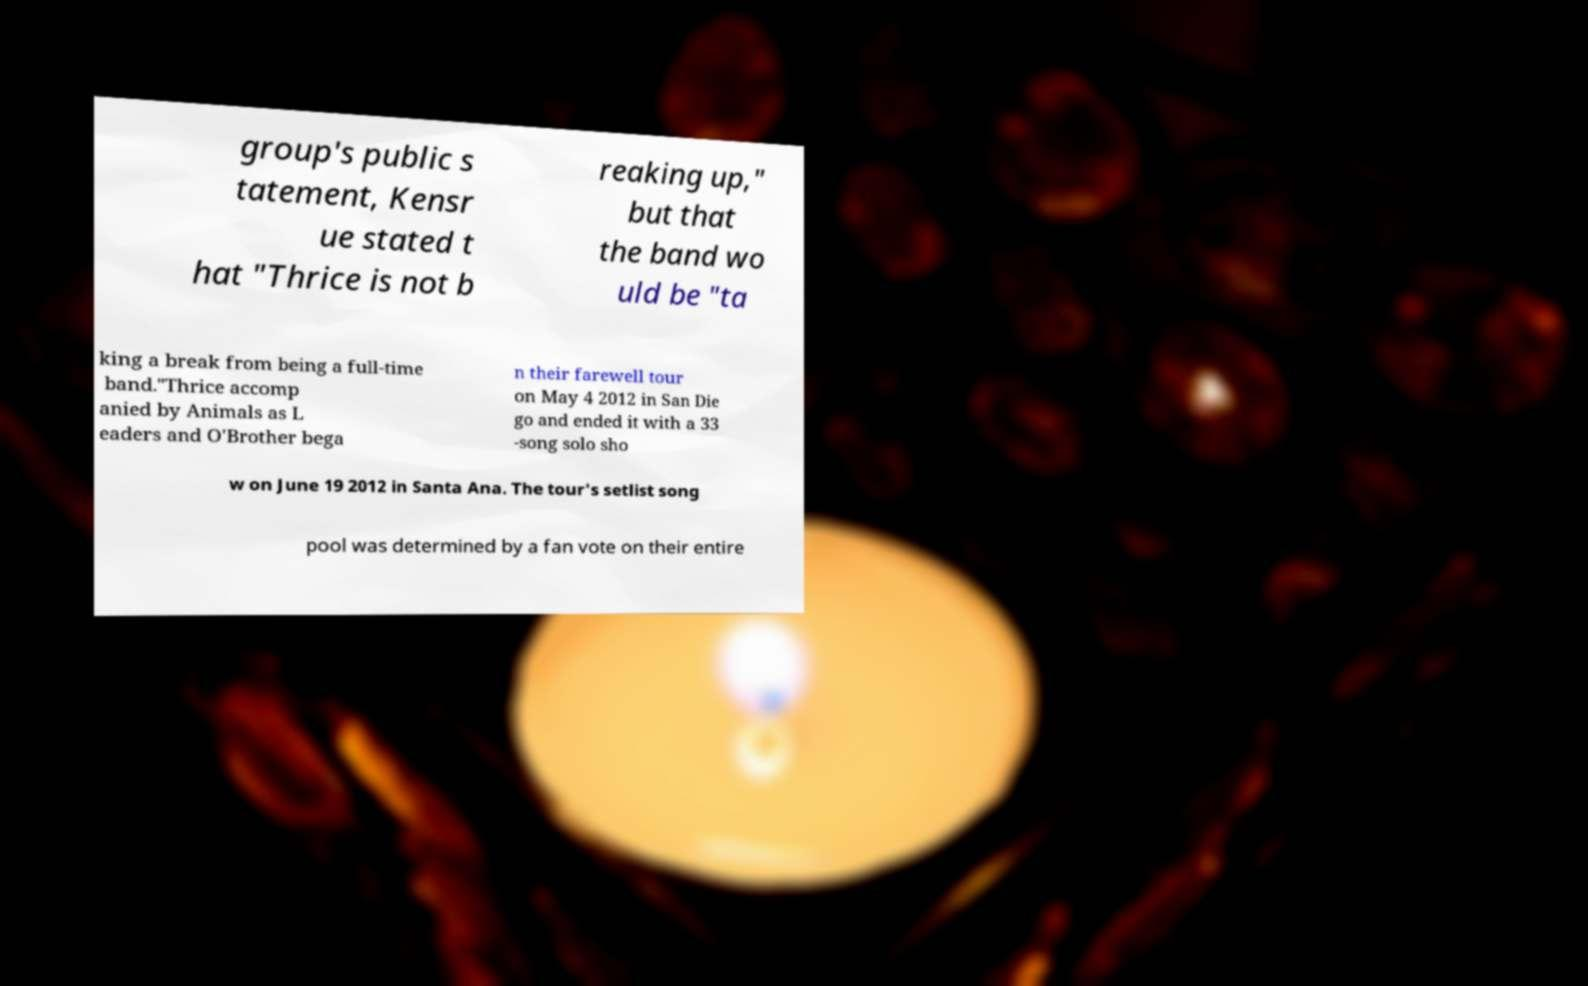Could you assist in decoding the text presented in this image and type it out clearly? group's public s tatement, Kensr ue stated t hat "Thrice is not b reaking up," but that the band wo uld be "ta king a break from being a full-time band."Thrice accomp anied by Animals as L eaders and O'Brother bega n their farewell tour on May 4 2012 in San Die go and ended it with a 33 -song solo sho w on June 19 2012 in Santa Ana. The tour's setlist song pool was determined by a fan vote on their entire 